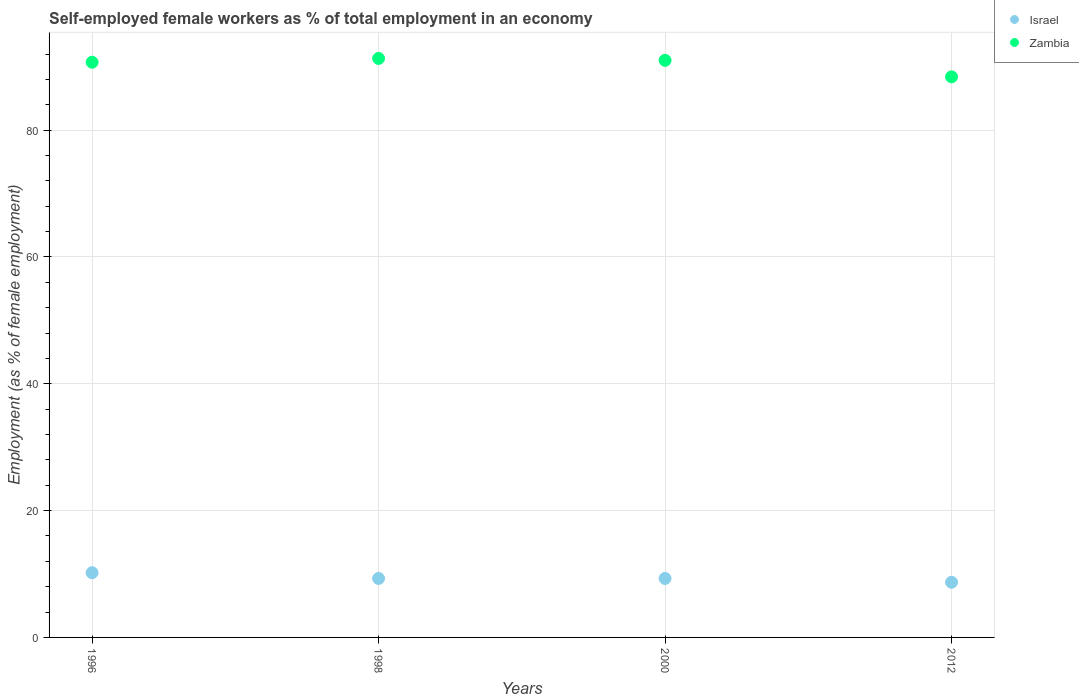How many different coloured dotlines are there?
Ensure brevity in your answer.  2. Is the number of dotlines equal to the number of legend labels?
Your answer should be very brief. Yes. What is the percentage of self-employed female workers in Zambia in 2000?
Offer a terse response. 91. Across all years, what is the maximum percentage of self-employed female workers in Zambia?
Provide a short and direct response. 91.3. Across all years, what is the minimum percentage of self-employed female workers in Israel?
Your response must be concise. 8.7. In which year was the percentage of self-employed female workers in Zambia maximum?
Keep it short and to the point. 1998. In which year was the percentage of self-employed female workers in Israel minimum?
Your answer should be compact. 2012. What is the total percentage of self-employed female workers in Zambia in the graph?
Your answer should be very brief. 361.4. What is the difference between the percentage of self-employed female workers in Israel in 1998 and the percentage of self-employed female workers in Zambia in 2012?
Offer a terse response. -79.1. What is the average percentage of self-employed female workers in Israel per year?
Your response must be concise. 9.37. In the year 2012, what is the difference between the percentage of self-employed female workers in Israel and percentage of self-employed female workers in Zambia?
Provide a succinct answer. -79.7. In how many years, is the percentage of self-employed female workers in Zambia greater than 56 %?
Your answer should be very brief. 4. What is the ratio of the percentage of self-employed female workers in Zambia in 1996 to that in 2012?
Keep it short and to the point. 1.03. Is the difference between the percentage of self-employed female workers in Israel in 1998 and 2012 greater than the difference between the percentage of self-employed female workers in Zambia in 1998 and 2012?
Your answer should be compact. No. What is the difference between the highest and the second highest percentage of self-employed female workers in Israel?
Your answer should be compact. 0.9. What is the difference between the highest and the lowest percentage of self-employed female workers in Israel?
Offer a terse response. 1.5. Is the sum of the percentage of self-employed female workers in Israel in 1998 and 2000 greater than the maximum percentage of self-employed female workers in Zambia across all years?
Provide a short and direct response. No. Is the percentage of self-employed female workers in Zambia strictly less than the percentage of self-employed female workers in Israel over the years?
Your answer should be very brief. No. How many dotlines are there?
Your answer should be very brief. 2. Does the graph contain any zero values?
Your answer should be compact. No. Where does the legend appear in the graph?
Give a very brief answer. Top right. What is the title of the graph?
Your answer should be very brief. Self-employed female workers as % of total employment in an economy. What is the label or title of the Y-axis?
Your answer should be compact. Employment (as % of female employment). What is the Employment (as % of female employment) in Israel in 1996?
Provide a short and direct response. 10.2. What is the Employment (as % of female employment) of Zambia in 1996?
Your answer should be very brief. 90.7. What is the Employment (as % of female employment) in Israel in 1998?
Your response must be concise. 9.3. What is the Employment (as % of female employment) of Zambia in 1998?
Ensure brevity in your answer.  91.3. What is the Employment (as % of female employment) in Israel in 2000?
Give a very brief answer. 9.3. What is the Employment (as % of female employment) of Zambia in 2000?
Give a very brief answer. 91. What is the Employment (as % of female employment) of Israel in 2012?
Ensure brevity in your answer.  8.7. What is the Employment (as % of female employment) in Zambia in 2012?
Provide a succinct answer. 88.4. Across all years, what is the maximum Employment (as % of female employment) of Israel?
Make the answer very short. 10.2. Across all years, what is the maximum Employment (as % of female employment) in Zambia?
Your answer should be very brief. 91.3. Across all years, what is the minimum Employment (as % of female employment) of Israel?
Provide a short and direct response. 8.7. Across all years, what is the minimum Employment (as % of female employment) in Zambia?
Provide a short and direct response. 88.4. What is the total Employment (as % of female employment) of Israel in the graph?
Your response must be concise. 37.5. What is the total Employment (as % of female employment) of Zambia in the graph?
Offer a terse response. 361.4. What is the difference between the Employment (as % of female employment) of Zambia in 1996 and that in 2012?
Your answer should be compact. 2.3. What is the difference between the Employment (as % of female employment) in Israel in 1998 and that in 2000?
Your answer should be compact. 0. What is the difference between the Employment (as % of female employment) of Israel in 1998 and that in 2012?
Make the answer very short. 0.6. What is the difference between the Employment (as % of female employment) of Zambia in 1998 and that in 2012?
Provide a succinct answer. 2.9. What is the difference between the Employment (as % of female employment) of Israel in 1996 and the Employment (as % of female employment) of Zambia in 1998?
Your answer should be compact. -81.1. What is the difference between the Employment (as % of female employment) of Israel in 1996 and the Employment (as % of female employment) of Zambia in 2000?
Ensure brevity in your answer.  -80.8. What is the difference between the Employment (as % of female employment) in Israel in 1996 and the Employment (as % of female employment) in Zambia in 2012?
Offer a terse response. -78.2. What is the difference between the Employment (as % of female employment) of Israel in 1998 and the Employment (as % of female employment) of Zambia in 2000?
Make the answer very short. -81.7. What is the difference between the Employment (as % of female employment) of Israel in 1998 and the Employment (as % of female employment) of Zambia in 2012?
Offer a terse response. -79.1. What is the difference between the Employment (as % of female employment) in Israel in 2000 and the Employment (as % of female employment) in Zambia in 2012?
Offer a very short reply. -79.1. What is the average Employment (as % of female employment) of Israel per year?
Provide a succinct answer. 9.38. What is the average Employment (as % of female employment) in Zambia per year?
Offer a very short reply. 90.35. In the year 1996, what is the difference between the Employment (as % of female employment) in Israel and Employment (as % of female employment) in Zambia?
Offer a terse response. -80.5. In the year 1998, what is the difference between the Employment (as % of female employment) of Israel and Employment (as % of female employment) of Zambia?
Make the answer very short. -82. In the year 2000, what is the difference between the Employment (as % of female employment) in Israel and Employment (as % of female employment) in Zambia?
Keep it short and to the point. -81.7. In the year 2012, what is the difference between the Employment (as % of female employment) in Israel and Employment (as % of female employment) in Zambia?
Provide a short and direct response. -79.7. What is the ratio of the Employment (as % of female employment) of Israel in 1996 to that in 1998?
Keep it short and to the point. 1.1. What is the ratio of the Employment (as % of female employment) in Zambia in 1996 to that in 1998?
Your answer should be compact. 0.99. What is the ratio of the Employment (as % of female employment) in Israel in 1996 to that in 2000?
Keep it short and to the point. 1.1. What is the ratio of the Employment (as % of female employment) in Zambia in 1996 to that in 2000?
Your answer should be very brief. 1. What is the ratio of the Employment (as % of female employment) in Israel in 1996 to that in 2012?
Keep it short and to the point. 1.17. What is the ratio of the Employment (as % of female employment) in Zambia in 1996 to that in 2012?
Provide a short and direct response. 1.03. What is the ratio of the Employment (as % of female employment) in Israel in 1998 to that in 2000?
Provide a short and direct response. 1. What is the ratio of the Employment (as % of female employment) of Zambia in 1998 to that in 2000?
Your answer should be very brief. 1. What is the ratio of the Employment (as % of female employment) in Israel in 1998 to that in 2012?
Make the answer very short. 1.07. What is the ratio of the Employment (as % of female employment) of Zambia in 1998 to that in 2012?
Provide a short and direct response. 1.03. What is the ratio of the Employment (as % of female employment) in Israel in 2000 to that in 2012?
Offer a terse response. 1.07. What is the ratio of the Employment (as % of female employment) of Zambia in 2000 to that in 2012?
Offer a terse response. 1.03. What is the difference between the highest and the second highest Employment (as % of female employment) of Israel?
Your answer should be compact. 0.9. What is the difference between the highest and the second highest Employment (as % of female employment) in Zambia?
Give a very brief answer. 0.3. 